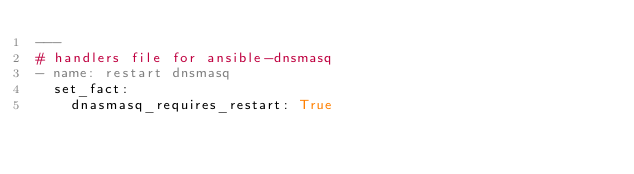<code> <loc_0><loc_0><loc_500><loc_500><_YAML_>---
# handlers file for ansible-dnsmasq
- name: restart dnsmasq
  set_fact:
    dnasmasq_requires_restart: True
</code> 